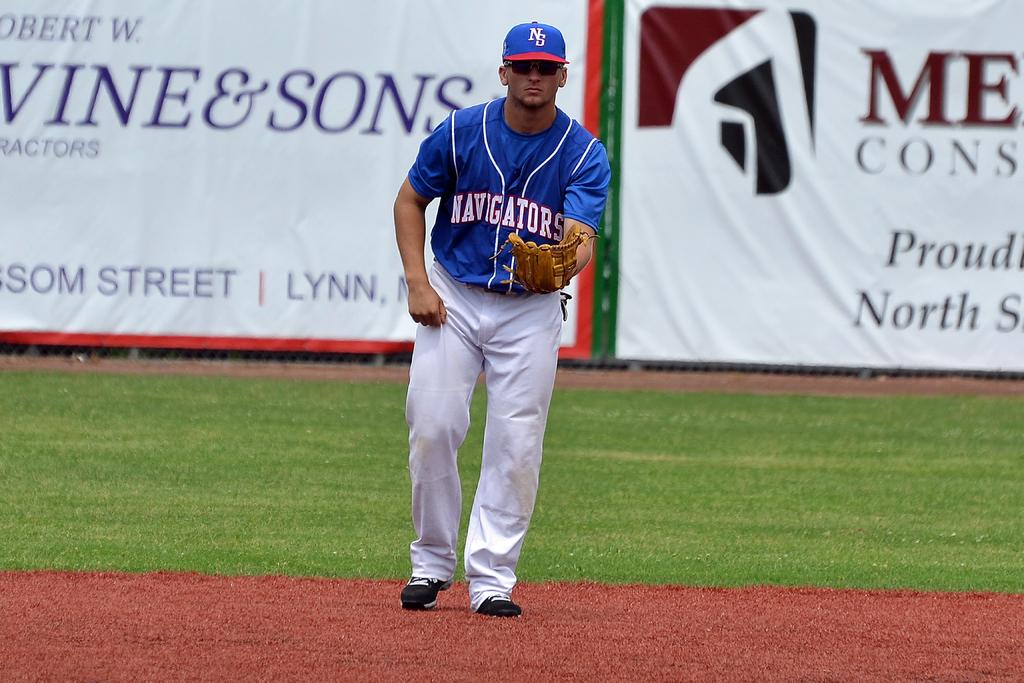What letters are on the mans hat?
Provide a succinct answer. Ns. 